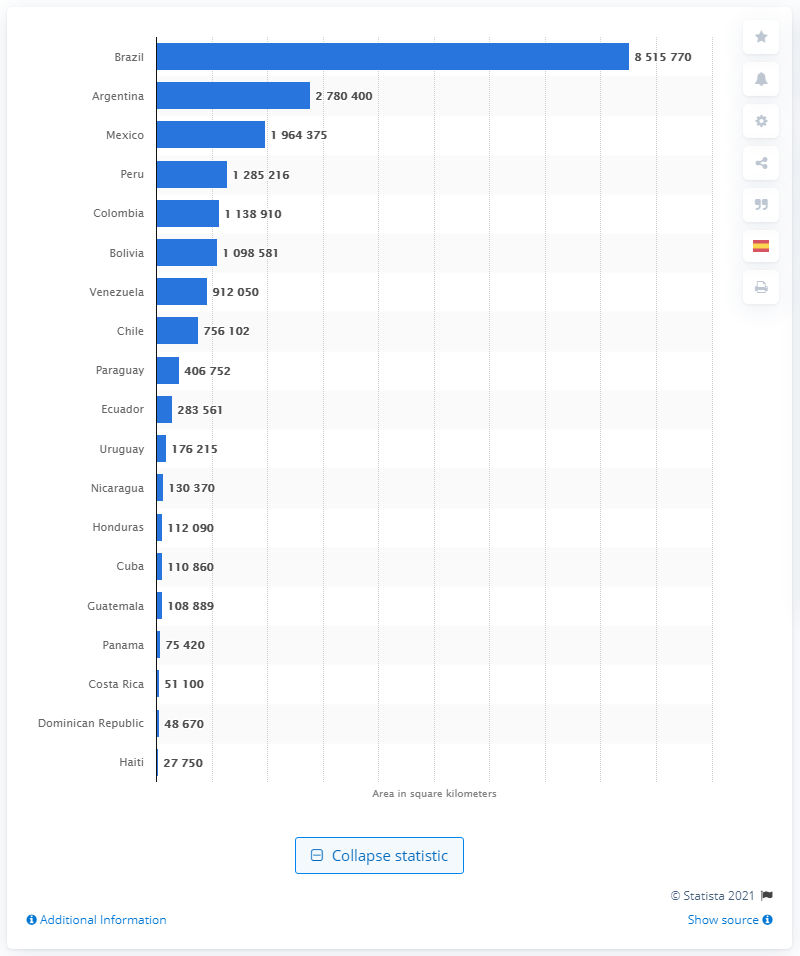Which countries are the smallest in Latin America according to this image? According to the graph, the smallest countries by land area in Latin America are Haiti, the Dominican Republic, and Costa Rica. 